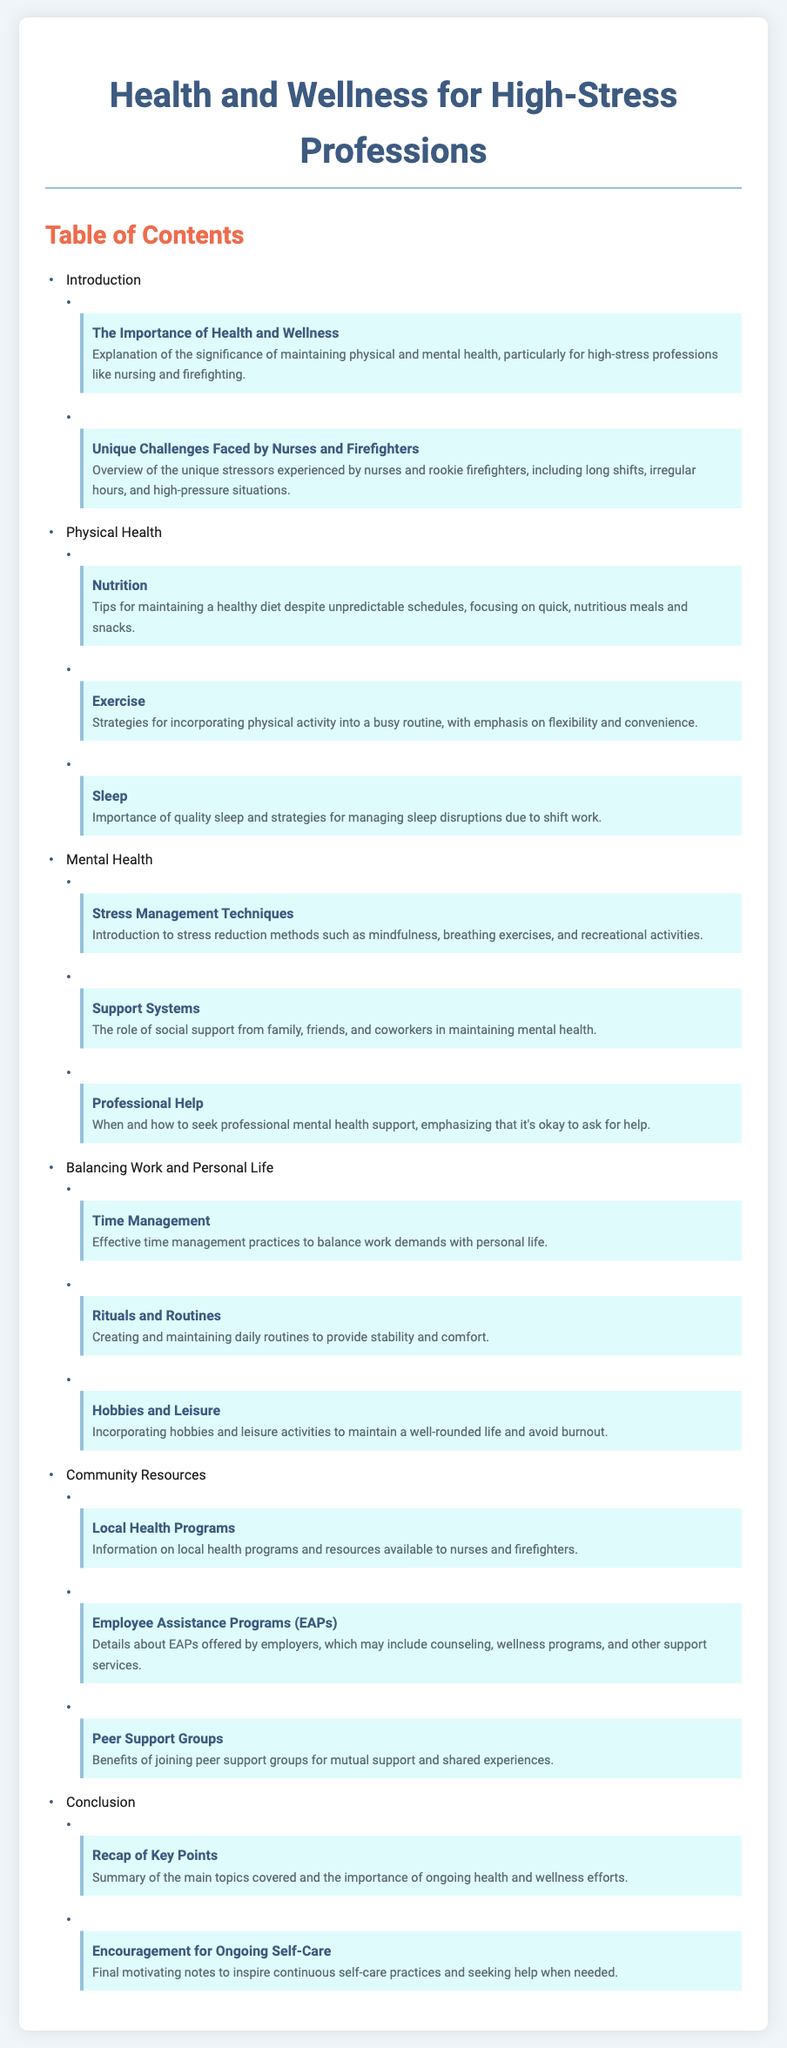What is the main topic of the document? The main topic of the document is about health and wellness for high-stress professions, focusing on maintaining physical and mental health.
Answer: Health and Wellness for High-Stress Professions How many subsections are listed under Physical Health? The document lists three subsections under Physical Health: Nutrition, Exercise, and Sleep.
Answer: 3 What is one technique mentioned for stress management? The document mentions mindfulness as one of the stress management techniques.
Answer: Mindfulness What role do support systems play in mental health? Support systems from family, friends, and coworkers are emphasized in the document for their importance in maintaining mental health.
Answer: Social support What is the purpose of Employee Assistance Programs (EAPs)? EAPs are designed to provide counseling, wellness programs, and other support services to employees.
Answer: Support services Which section contains information on hobbies and leisure? The section on Balancing Work and Personal Life contains information on hobbies and leisure activities.
Answer: Balancing Work and Personal Life How many total sections are mentioned in the document? There are six main sections listed in the document: Introduction, Physical Health, Mental Health, Balancing Work and Personal Life, Community Resources, and Conclusion.
Answer: 6 What is emphasized as crucial for sleep management? The importance of quality sleep is emphasized in the document as crucial for managing sleep disruptions due to shift work.
Answer: Quality sleep What is the final encouraging note in the Conclusion? The final motivating note encourages ongoing self-care practices and seeking help when needed.
Answer: Ongoing self-care practices 